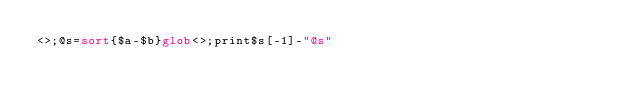Convert code to text. <code><loc_0><loc_0><loc_500><loc_500><_Perl_><>;@s=sort{$a-$b}glob<>;print$s[-1]-"@s"</code> 